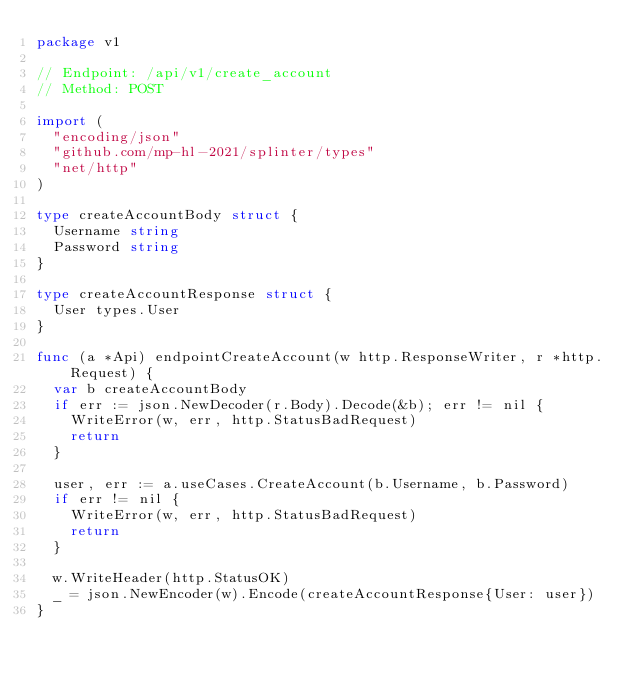<code> <loc_0><loc_0><loc_500><loc_500><_Go_>package v1

// Endpoint: /api/v1/create_account
// Method: POST

import (
	"encoding/json"
	"github.com/mp-hl-2021/splinter/types"
	"net/http"
)

type createAccountBody struct {
	Username string
	Password string
}

type createAccountResponse struct {
	User types.User
}

func (a *Api) endpointCreateAccount(w http.ResponseWriter, r *http.Request) {
	var b createAccountBody
	if err := json.NewDecoder(r.Body).Decode(&b); err != nil {
		WriteError(w, err, http.StatusBadRequest)
		return
	}

	user, err := a.useCases.CreateAccount(b.Username, b.Password)
	if err != nil {
		WriteError(w, err, http.StatusBadRequest)
		return
	}

	w.WriteHeader(http.StatusOK)
	_ = json.NewEncoder(w).Encode(createAccountResponse{User: user})
}
</code> 